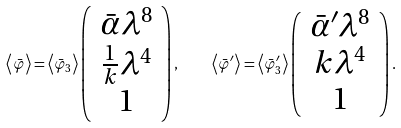Convert formula to latex. <formula><loc_0><loc_0><loc_500><loc_500>\left \langle \bar { \varphi } \right \rangle = \left \langle \bar { \varphi } _ { 3 } \right \rangle \left ( \begin{array} { c } \bar { \alpha } \lambda ^ { 8 } \\ \frac { 1 } { k } \lambda ^ { 4 } \\ 1 \end{array} \right ) , \quad \left \langle \bar { \varphi } ^ { \prime } \right \rangle = \left \langle \bar { \varphi } _ { 3 } ^ { \prime } \right \rangle \left ( \begin{array} { c } \bar { \alpha } ^ { \prime } \lambda ^ { 8 } \\ k \lambda ^ { 4 } \\ 1 \end{array} \right ) .</formula> 